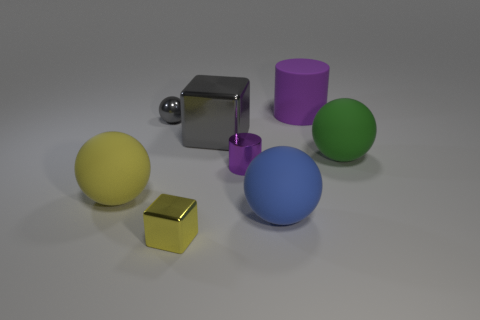Is there any other thing that has the same shape as the tiny yellow metallic object?
Offer a very short reply. Yes. Is the number of big green matte things greater than the number of balls?
Offer a very short reply. No. How many other objects are the same material as the small gray ball?
Your answer should be very brief. 3. There is a purple thing behind the small metallic object behind the matte sphere on the right side of the large blue thing; what shape is it?
Your answer should be compact. Cylinder. Is the number of objects in front of the tiny yellow thing less than the number of gray metallic blocks that are behind the big purple rubber thing?
Provide a short and direct response. No. Are there any other matte balls that have the same color as the small sphere?
Make the answer very short. No. Are the tiny purple object and the purple cylinder on the right side of the tiny purple shiny cylinder made of the same material?
Provide a succinct answer. No. There is a large rubber object that is behind the shiny ball; is there a large purple matte cylinder that is on the left side of it?
Make the answer very short. No. What color is the thing that is behind the large gray metallic thing and left of the large gray thing?
Offer a terse response. Gray. What size is the gray cube?
Offer a very short reply. Large. 